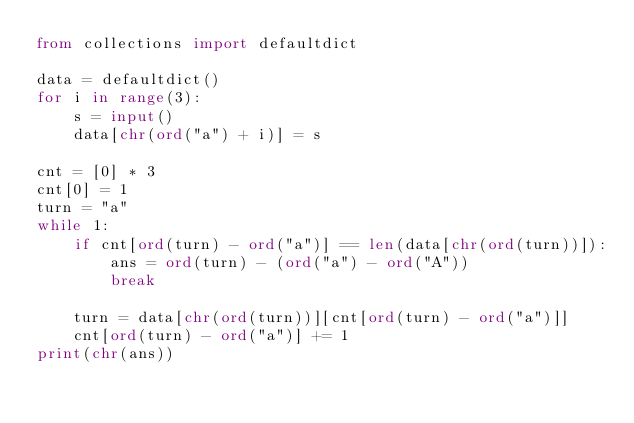Convert code to text. <code><loc_0><loc_0><loc_500><loc_500><_Python_>from collections import defaultdict

data = defaultdict()
for i in range(3):
    s = input()
    data[chr(ord("a") + i)] = s

cnt = [0] * 3
cnt[0] = 1
turn = "a"
while 1:
    if cnt[ord(turn) - ord("a")] == len(data[chr(ord(turn))]):
        ans = ord(turn) - (ord("a") - ord("A"))
        break

    turn = data[chr(ord(turn))][cnt[ord(turn) - ord("a")]]
    cnt[ord(turn) - ord("a")] += 1
print(chr(ans))</code> 